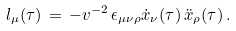<formula> <loc_0><loc_0><loc_500><loc_500>l _ { \mu } ( \tau ) \, = \, - v ^ { - 2 } \, \epsilon _ { \mu \nu \rho } \dot { x } _ { \nu } ( \tau ) \, \ddot { x } _ { \rho } ( \tau ) \, .</formula> 